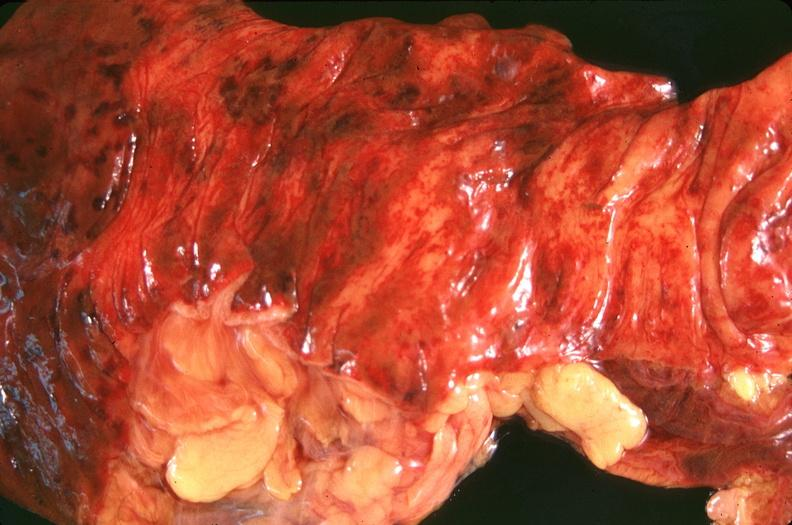does this image show small intestine, ischemic bowel?
Answer the question using a single word or phrase. Yes 